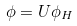<formula> <loc_0><loc_0><loc_500><loc_500>\phi = U \phi _ { H }</formula> 